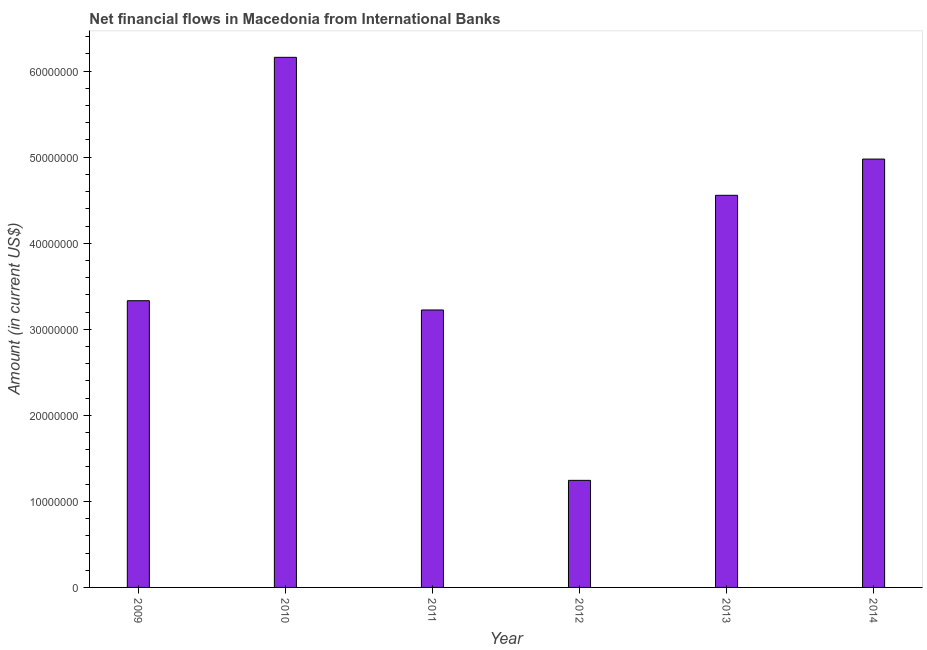Does the graph contain any zero values?
Offer a terse response. No. What is the title of the graph?
Make the answer very short. Net financial flows in Macedonia from International Banks. What is the net financial flows from ibrd in 2013?
Offer a terse response. 4.56e+07. Across all years, what is the maximum net financial flows from ibrd?
Your answer should be very brief. 6.16e+07. Across all years, what is the minimum net financial flows from ibrd?
Give a very brief answer. 1.24e+07. What is the sum of the net financial flows from ibrd?
Your answer should be very brief. 2.35e+08. What is the difference between the net financial flows from ibrd in 2011 and 2012?
Offer a terse response. 1.98e+07. What is the average net financial flows from ibrd per year?
Make the answer very short. 3.92e+07. What is the median net financial flows from ibrd?
Make the answer very short. 3.94e+07. What is the ratio of the net financial flows from ibrd in 2009 to that in 2010?
Ensure brevity in your answer.  0.54. Is the net financial flows from ibrd in 2012 less than that in 2014?
Keep it short and to the point. Yes. Is the difference between the net financial flows from ibrd in 2011 and 2013 greater than the difference between any two years?
Offer a very short reply. No. What is the difference between the highest and the second highest net financial flows from ibrd?
Offer a terse response. 1.18e+07. Is the sum of the net financial flows from ibrd in 2009 and 2011 greater than the maximum net financial flows from ibrd across all years?
Provide a succinct answer. Yes. What is the difference between the highest and the lowest net financial flows from ibrd?
Ensure brevity in your answer.  4.92e+07. In how many years, is the net financial flows from ibrd greater than the average net financial flows from ibrd taken over all years?
Ensure brevity in your answer.  3. How many bars are there?
Your answer should be very brief. 6. Are all the bars in the graph horizontal?
Your response must be concise. No. What is the difference between two consecutive major ticks on the Y-axis?
Keep it short and to the point. 1.00e+07. Are the values on the major ticks of Y-axis written in scientific E-notation?
Offer a terse response. No. What is the Amount (in current US$) in 2009?
Give a very brief answer. 3.33e+07. What is the Amount (in current US$) of 2010?
Give a very brief answer. 6.16e+07. What is the Amount (in current US$) of 2011?
Provide a short and direct response. 3.22e+07. What is the Amount (in current US$) of 2012?
Provide a short and direct response. 1.24e+07. What is the Amount (in current US$) of 2013?
Provide a succinct answer. 4.56e+07. What is the Amount (in current US$) in 2014?
Provide a succinct answer. 4.98e+07. What is the difference between the Amount (in current US$) in 2009 and 2010?
Your answer should be very brief. -2.83e+07. What is the difference between the Amount (in current US$) in 2009 and 2011?
Provide a succinct answer. 1.08e+06. What is the difference between the Amount (in current US$) in 2009 and 2012?
Offer a terse response. 2.09e+07. What is the difference between the Amount (in current US$) in 2009 and 2013?
Your response must be concise. -1.22e+07. What is the difference between the Amount (in current US$) in 2009 and 2014?
Offer a terse response. -1.65e+07. What is the difference between the Amount (in current US$) in 2010 and 2011?
Provide a succinct answer. 2.94e+07. What is the difference between the Amount (in current US$) in 2010 and 2012?
Your answer should be compact. 4.92e+07. What is the difference between the Amount (in current US$) in 2010 and 2013?
Your answer should be compact. 1.60e+07. What is the difference between the Amount (in current US$) in 2010 and 2014?
Your response must be concise. 1.18e+07. What is the difference between the Amount (in current US$) in 2011 and 2012?
Offer a very short reply. 1.98e+07. What is the difference between the Amount (in current US$) in 2011 and 2013?
Provide a short and direct response. -1.33e+07. What is the difference between the Amount (in current US$) in 2011 and 2014?
Provide a succinct answer. -1.75e+07. What is the difference between the Amount (in current US$) in 2012 and 2013?
Your answer should be very brief. -3.31e+07. What is the difference between the Amount (in current US$) in 2012 and 2014?
Provide a succinct answer. -3.73e+07. What is the difference between the Amount (in current US$) in 2013 and 2014?
Make the answer very short. -4.21e+06. What is the ratio of the Amount (in current US$) in 2009 to that in 2010?
Provide a short and direct response. 0.54. What is the ratio of the Amount (in current US$) in 2009 to that in 2011?
Ensure brevity in your answer.  1.03. What is the ratio of the Amount (in current US$) in 2009 to that in 2012?
Offer a terse response. 2.68. What is the ratio of the Amount (in current US$) in 2009 to that in 2013?
Provide a short and direct response. 0.73. What is the ratio of the Amount (in current US$) in 2009 to that in 2014?
Make the answer very short. 0.67. What is the ratio of the Amount (in current US$) in 2010 to that in 2011?
Keep it short and to the point. 1.91. What is the ratio of the Amount (in current US$) in 2010 to that in 2012?
Give a very brief answer. 4.95. What is the ratio of the Amount (in current US$) in 2010 to that in 2013?
Your answer should be very brief. 1.35. What is the ratio of the Amount (in current US$) in 2010 to that in 2014?
Offer a terse response. 1.24. What is the ratio of the Amount (in current US$) in 2011 to that in 2012?
Offer a terse response. 2.59. What is the ratio of the Amount (in current US$) in 2011 to that in 2013?
Ensure brevity in your answer.  0.71. What is the ratio of the Amount (in current US$) in 2011 to that in 2014?
Offer a terse response. 0.65. What is the ratio of the Amount (in current US$) in 2012 to that in 2013?
Provide a succinct answer. 0.27. What is the ratio of the Amount (in current US$) in 2012 to that in 2014?
Make the answer very short. 0.25. What is the ratio of the Amount (in current US$) in 2013 to that in 2014?
Keep it short and to the point. 0.92. 